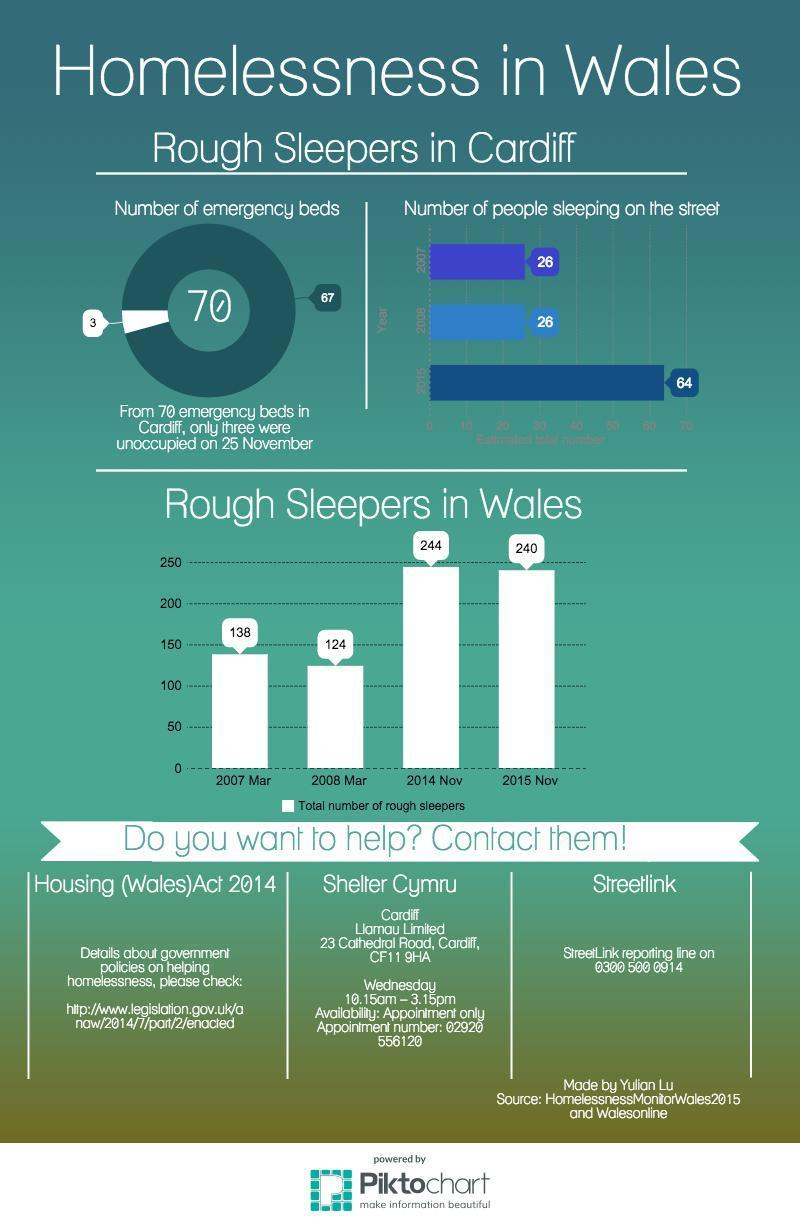How much increase in number of rough sleepers in Wales happened from March 2007 to November 2015?
Answer the question with a short phrase. 102 How much increase in number of rough sleepers in Wales happened from March 2008 to November 2014? 100 How much decrease in number of rough sleepers in Wales happened from March 2007 to March 2008? 14 How much decrease in number of rough sleepers in Wales happened from November 2014 to November 2015? 4 